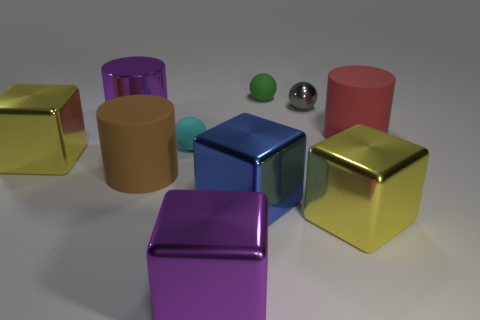There is a purple metal cube; is its size the same as the matte sphere that is in front of the small green rubber object? The purple metal cube is actually larger in size compared to the matte sphere located in front of the small green rubber object. 